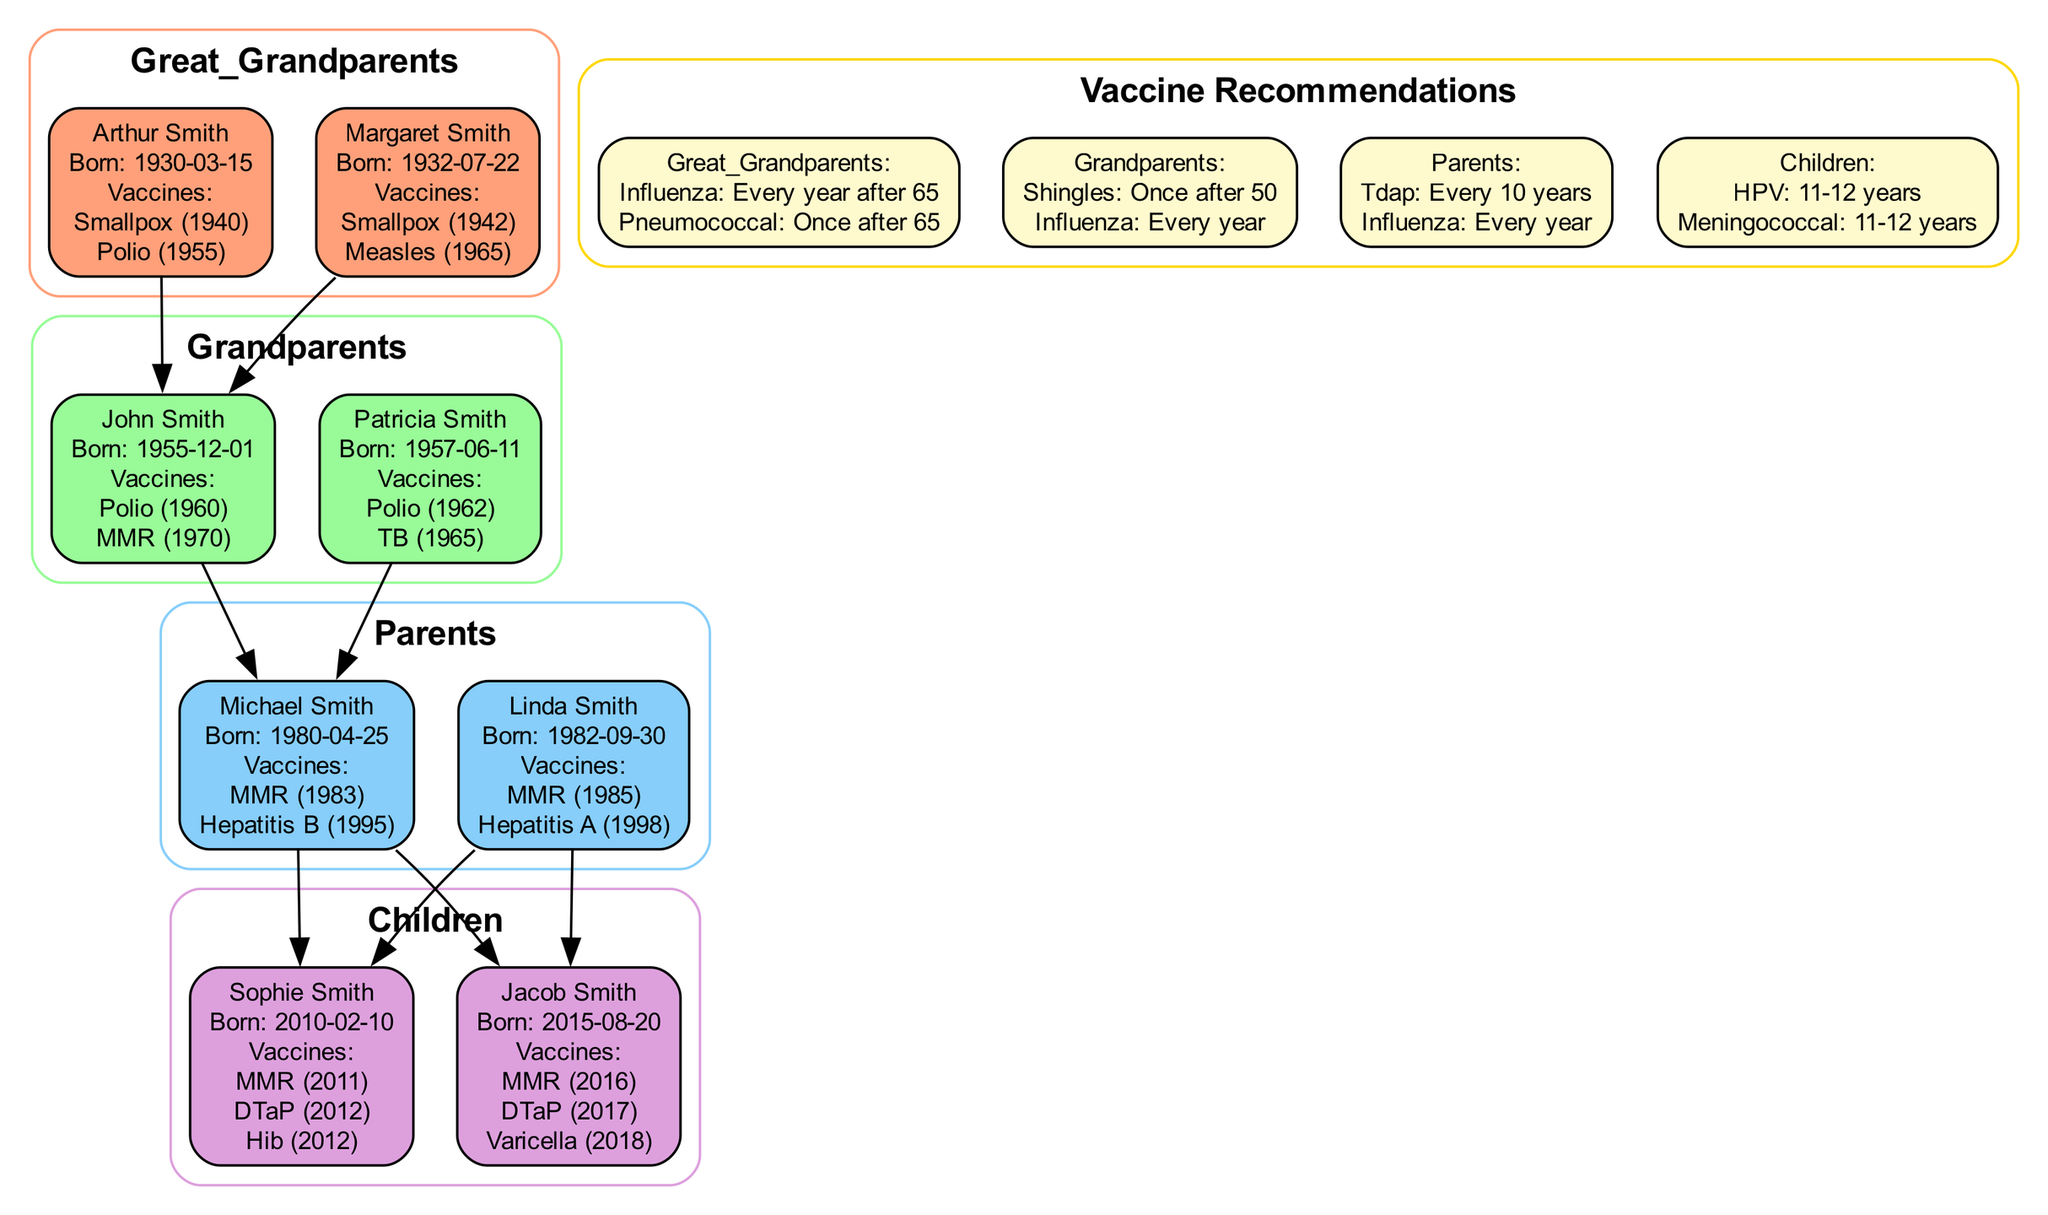What vaccines did Michael Smith receive? Michael Smith received the MMR vaccine in 1983 and the Hepatitis B vaccine in 1995, as listed under his vaccinations in the diagram.
Answer: MMR (1983), Hepatitis B (1995) How many total vaccines did Sophie Smith receive? Sophie Smith received a total of three vaccines: MMR in 2011, DTaP in 2012, and Hib in 2012, which can be counted directly from her vaccination list.
Answer: 3 Who are the great-grandparents of Sophie Smith? The great-grandparents of Sophie Smith are Arthur Smith and Margaret Smith, indicated by the lineage path connecting them to her parents.
Answer: Arthur Smith, Margaret Smith What is the recommended age for the shingles vaccine? The shingles vaccine is recommended once after the age of 50, as mentioned in the recommendations section for grandparents.
Answer: Once after 50 Which generation has the most vaccine recommendations listed? The generation with the most vaccine recommendations listed is 'Parents', which has two vaccinations: Tdap and Influenza for every 10 years and every year, respectively.
Answer: Parents How many children did Michael and Linda Smith have? Michael and Linda Smith have two children, Sophie and Jacob Smith, which is indicated by the edges connecting them to their children in the diagram.
Answer: 2 What is Jacob Smith's birthdate? Jacob Smith's birthdate is August 20, 2015, which is clearly stated next to his name in the diagram under the children section.
Answer: 2015-08-20 Which great-grandparent received the smallpox vaccine in 1942? The great-grandparent that received the smallpox vaccine in 1942 is Margaret Smith, as her vaccination details are listed in the diagram.
Answer: Margaret Smith What vaccinations are recommended for children aged 11-12 years? For children aged 11-12 years, the recommended vaccinations are HPV and Meningococcal, as shown in the children’s recommendation section of the diagram.
Answer: HPV, Meningococcal 